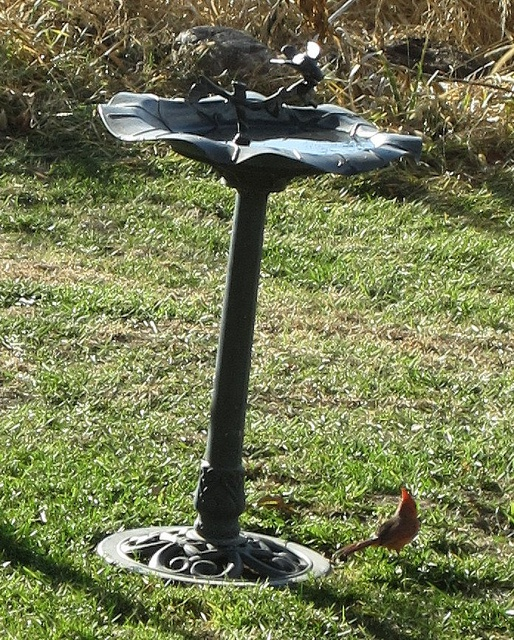Describe the objects in this image and their specific colors. I can see bird in tan, gray, black, and darkgray tones and bird in tan, black, maroon, darkgreen, and gray tones in this image. 